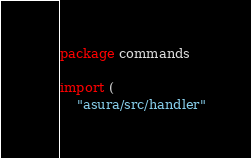<code> <loc_0><loc_0><loc_500><loc_500><_Go_>package commands

import (
	"asura/src/handler"</code> 